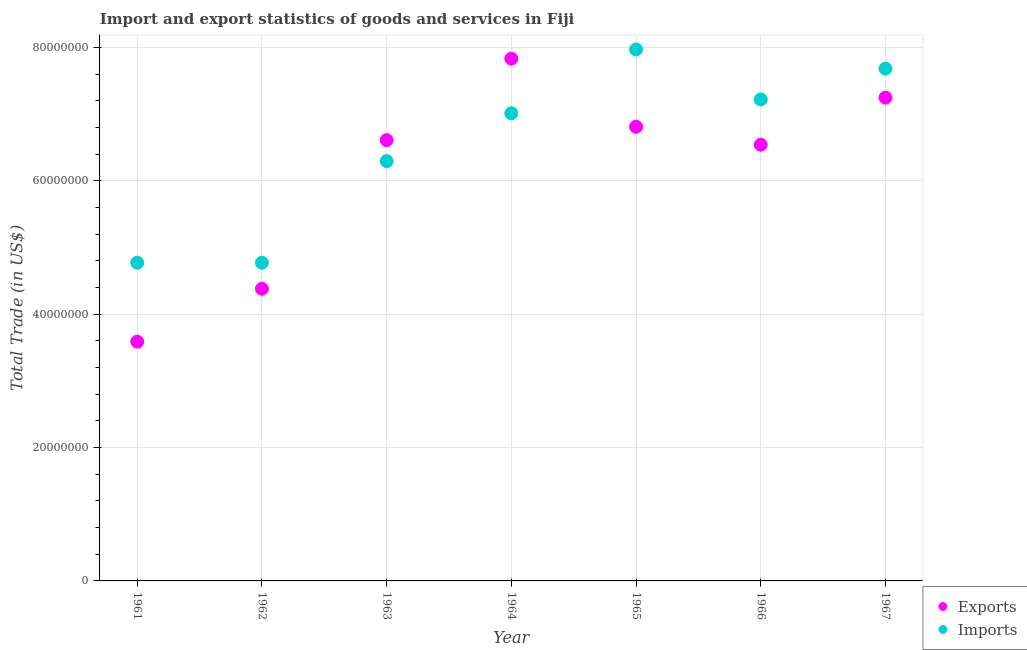How many different coloured dotlines are there?
Give a very brief answer. 2. What is the imports of goods and services in 1966?
Your answer should be very brief. 7.22e+07. Across all years, what is the maximum export of goods and services?
Your response must be concise. 7.83e+07. Across all years, what is the minimum imports of goods and services?
Ensure brevity in your answer.  4.77e+07. In which year was the export of goods and services maximum?
Your answer should be very brief. 1964. What is the total export of goods and services in the graph?
Make the answer very short. 4.30e+08. What is the difference between the export of goods and services in 1965 and that in 1967?
Make the answer very short. -4.36e+06. What is the difference between the export of goods and services in 1962 and the imports of goods and services in 1961?
Keep it short and to the point. -3.90e+06. What is the average export of goods and services per year?
Offer a terse response. 6.15e+07. In the year 1963, what is the difference between the imports of goods and services and export of goods and services?
Keep it short and to the point. -3.15e+06. What is the ratio of the imports of goods and services in 1962 to that in 1965?
Your answer should be very brief. 0.6. What is the difference between the highest and the second highest imports of goods and services?
Keep it short and to the point. 2.88e+06. What is the difference between the highest and the lowest imports of goods and services?
Keep it short and to the point. 3.20e+07. Is the sum of the imports of goods and services in 1965 and 1966 greater than the maximum export of goods and services across all years?
Offer a very short reply. Yes. Is the export of goods and services strictly greater than the imports of goods and services over the years?
Your response must be concise. No. How many dotlines are there?
Provide a succinct answer. 2. How many years are there in the graph?
Keep it short and to the point. 7. What is the difference between two consecutive major ticks on the Y-axis?
Your answer should be very brief. 2.00e+07. Does the graph contain any zero values?
Make the answer very short. No. How are the legend labels stacked?
Offer a terse response. Vertical. What is the title of the graph?
Keep it short and to the point. Import and export statistics of goods and services in Fiji. What is the label or title of the X-axis?
Keep it short and to the point. Year. What is the label or title of the Y-axis?
Your answer should be compact. Total Trade (in US$). What is the Total Trade (in US$) of Exports in 1961?
Your answer should be compact. 3.59e+07. What is the Total Trade (in US$) in Imports in 1961?
Offer a very short reply. 4.77e+07. What is the Total Trade (in US$) of Exports in 1962?
Offer a terse response. 4.38e+07. What is the Total Trade (in US$) of Imports in 1962?
Provide a short and direct response. 4.77e+07. What is the Total Trade (in US$) of Exports in 1963?
Provide a short and direct response. 6.61e+07. What is the Total Trade (in US$) in Imports in 1963?
Keep it short and to the point. 6.30e+07. What is the Total Trade (in US$) of Exports in 1964?
Keep it short and to the point. 7.83e+07. What is the Total Trade (in US$) of Imports in 1964?
Make the answer very short. 7.01e+07. What is the Total Trade (in US$) of Exports in 1965?
Make the answer very short. 6.81e+07. What is the Total Trade (in US$) of Imports in 1965?
Give a very brief answer. 7.97e+07. What is the Total Trade (in US$) in Exports in 1966?
Give a very brief answer. 6.54e+07. What is the Total Trade (in US$) in Imports in 1966?
Your response must be concise. 7.22e+07. What is the Total Trade (in US$) in Exports in 1967?
Your response must be concise. 7.25e+07. What is the Total Trade (in US$) in Imports in 1967?
Ensure brevity in your answer.  7.68e+07. Across all years, what is the maximum Total Trade (in US$) of Exports?
Keep it short and to the point. 7.83e+07. Across all years, what is the maximum Total Trade (in US$) in Imports?
Your answer should be compact. 7.97e+07. Across all years, what is the minimum Total Trade (in US$) in Exports?
Your response must be concise. 3.59e+07. Across all years, what is the minimum Total Trade (in US$) in Imports?
Ensure brevity in your answer.  4.77e+07. What is the total Total Trade (in US$) of Exports in the graph?
Provide a succinct answer. 4.30e+08. What is the total Total Trade (in US$) in Imports in the graph?
Keep it short and to the point. 4.57e+08. What is the difference between the Total Trade (in US$) in Exports in 1961 and that in 1962?
Ensure brevity in your answer.  -7.93e+06. What is the difference between the Total Trade (in US$) of Imports in 1961 and that in 1962?
Give a very brief answer. 0. What is the difference between the Total Trade (in US$) in Exports in 1961 and that in 1963?
Make the answer very short. -3.02e+07. What is the difference between the Total Trade (in US$) of Imports in 1961 and that in 1963?
Keep it short and to the point. -1.52e+07. What is the difference between the Total Trade (in US$) of Exports in 1961 and that in 1964?
Provide a short and direct response. -4.24e+07. What is the difference between the Total Trade (in US$) in Imports in 1961 and that in 1964?
Your response must be concise. -2.24e+07. What is the difference between the Total Trade (in US$) in Exports in 1961 and that in 1965?
Keep it short and to the point. -3.22e+07. What is the difference between the Total Trade (in US$) in Imports in 1961 and that in 1965?
Ensure brevity in your answer.  -3.20e+07. What is the difference between the Total Trade (in US$) of Exports in 1961 and that in 1966?
Make the answer very short. -2.95e+07. What is the difference between the Total Trade (in US$) of Imports in 1961 and that in 1966?
Your answer should be very brief. -2.45e+07. What is the difference between the Total Trade (in US$) of Exports in 1961 and that in 1967?
Your response must be concise. -3.66e+07. What is the difference between the Total Trade (in US$) of Imports in 1961 and that in 1967?
Keep it short and to the point. -2.91e+07. What is the difference between the Total Trade (in US$) in Exports in 1962 and that in 1963?
Keep it short and to the point. -2.23e+07. What is the difference between the Total Trade (in US$) in Imports in 1962 and that in 1963?
Your response must be concise. -1.52e+07. What is the difference between the Total Trade (in US$) in Exports in 1962 and that in 1964?
Provide a short and direct response. -3.45e+07. What is the difference between the Total Trade (in US$) in Imports in 1962 and that in 1964?
Your answer should be compact. -2.24e+07. What is the difference between the Total Trade (in US$) in Exports in 1962 and that in 1965?
Give a very brief answer. -2.43e+07. What is the difference between the Total Trade (in US$) in Imports in 1962 and that in 1965?
Make the answer very short. -3.20e+07. What is the difference between the Total Trade (in US$) in Exports in 1962 and that in 1966?
Offer a very short reply. -2.16e+07. What is the difference between the Total Trade (in US$) in Imports in 1962 and that in 1966?
Your response must be concise. -2.45e+07. What is the difference between the Total Trade (in US$) of Exports in 1962 and that in 1967?
Ensure brevity in your answer.  -2.87e+07. What is the difference between the Total Trade (in US$) of Imports in 1962 and that in 1967?
Offer a very short reply. -2.91e+07. What is the difference between the Total Trade (in US$) in Exports in 1963 and that in 1964?
Offer a very short reply. -1.22e+07. What is the difference between the Total Trade (in US$) of Imports in 1963 and that in 1964?
Your response must be concise. -7.18e+06. What is the difference between the Total Trade (in US$) of Exports in 1963 and that in 1965?
Offer a very short reply. -2.01e+06. What is the difference between the Total Trade (in US$) of Imports in 1963 and that in 1965?
Keep it short and to the point. -1.67e+07. What is the difference between the Total Trade (in US$) in Exports in 1963 and that in 1966?
Ensure brevity in your answer.  6.91e+05. What is the difference between the Total Trade (in US$) of Imports in 1963 and that in 1966?
Your response must be concise. -9.25e+06. What is the difference between the Total Trade (in US$) in Exports in 1963 and that in 1967?
Make the answer very short. -6.37e+06. What is the difference between the Total Trade (in US$) in Imports in 1963 and that in 1967?
Ensure brevity in your answer.  -1.39e+07. What is the difference between the Total Trade (in US$) of Exports in 1964 and that in 1965?
Your answer should be very brief. 1.02e+07. What is the difference between the Total Trade (in US$) in Imports in 1964 and that in 1965?
Your answer should be compact. -9.57e+06. What is the difference between the Total Trade (in US$) in Exports in 1964 and that in 1966?
Give a very brief answer. 1.29e+07. What is the difference between the Total Trade (in US$) of Imports in 1964 and that in 1966?
Your answer should be very brief. -2.07e+06. What is the difference between the Total Trade (in US$) of Exports in 1964 and that in 1967?
Offer a terse response. 5.85e+06. What is the difference between the Total Trade (in US$) of Imports in 1964 and that in 1967?
Your answer should be compact. -6.69e+06. What is the difference between the Total Trade (in US$) in Exports in 1965 and that in 1966?
Make the answer very short. 2.70e+06. What is the difference between the Total Trade (in US$) in Imports in 1965 and that in 1966?
Make the answer very short. 7.49e+06. What is the difference between the Total Trade (in US$) in Exports in 1965 and that in 1967?
Provide a succinct answer. -4.36e+06. What is the difference between the Total Trade (in US$) in Imports in 1965 and that in 1967?
Your answer should be very brief. 2.88e+06. What is the difference between the Total Trade (in US$) of Exports in 1966 and that in 1967?
Keep it short and to the point. -7.06e+06. What is the difference between the Total Trade (in US$) of Imports in 1966 and that in 1967?
Make the answer very short. -4.62e+06. What is the difference between the Total Trade (in US$) of Exports in 1961 and the Total Trade (in US$) of Imports in 1962?
Offer a very short reply. -1.18e+07. What is the difference between the Total Trade (in US$) of Exports in 1961 and the Total Trade (in US$) of Imports in 1963?
Your response must be concise. -2.71e+07. What is the difference between the Total Trade (in US$) of Exports in 1961 and the Total Trade (in US$) of Imports in 1964?
Give a very brief answer. -3.43e+07. What is the difference between the Total Trade (in US$) of Exports in 1961 and the Total Trade (in US$) of Imports in 1965?
Keep it short and to the point. -4.38e+07. What is the difference between the Total Trade (in US$) in Exports in 1961 and the Total Trade (in US$) in Imports in 1966?
Provide a short and direct response. -3.63e+07. What is the difference between the Total Trade (in US$) in Exports in 1961 and the Total Trade (in US$) in Imports in 1967?
Your answer should be very brief. -4.09e+07. What is the difference between the Total Trade (in US$) of Exports in 1962 and the Total Trade (in US$) of Imports in 1963?
Provide a succinct answer. -1.91e+07. What is the difference between the Total Trade (in US$) of Exports in 1962 and the Total Trade (in US$) of Imports in 1964?
Your response must be concise. -2.63e+07. What is the difference between the Total Trade (in US$) in Exports in 1962 and the Total Trade (in US$) in Imports in 1965?
Offer a very short reply. -3.59e+07. What is the difference between the Total Trade (in US$) in Exports in 1962 and the Total Trade (in US$) in Imports in 1966?
Provide a short and direct response. -2.84e+07. What is the difference between the Total Trade (in US$) in Exports in 1962 and the Total Trade (in US$) in Imports in 1967?
Ensure brevity in your answer.  -3.30e+07. What is the difference between the Total Trade (in US$) of Exports in 1963 and the Total Trade (in US$) of Imports in 1964?
Provide a short and direct response. -4.03e+06. What is the difference between the Total Trade (in US$) of Exports in 1963 and the Total Trade (in US$) of Imports in 1965?
Provide a succinct answer. -1.36e+07. What is the difference between the Total Trade (in US$) in Exports in 1963 and the Total Trade (in US$) in Imports in 1966?
Ensure brevity in your answer.  -6.10e+06. What is the difference between the Total Trade (in US$) in Exports in 1963 and the Total Trade (in US$) in Imports in 1967?
Offer a very short reply. -1.07e+07. What is the difference between the Total Trade (in US$) of Exports in 1964 and the Total Trade (in US$) of Imports in 1965?
Provide a succinct answer. -1.38e+06. What is the difference between the Total Trade (in US$) in Exports in 1964 and the Total Trade (in US$) in Imports in 1966?
Your answer should be very brief. 6.11e+06. What is the difference between the Total Trade (in US$) in Exports in 1964 and the Total Trade (in US$) in Imports in 1967?
Offer a very short reply. 1.49e+06. What is the difference between the Total Trade (in US$) in Exports in 1965 and the Total Trade (in US$) in Imports in 1966?
Provide a succinct answer. -4.09e+06. What is the difference between the Total Trade (in US$) of Exports in 1965 and the Total Trade (in US$) of Imports in 1967?
Your response must be concise. -8.71e+06. What is the difference between the Total Trade (in US$) in Exports in 1966 and the Total Trade (in US$) in Imports in 1967?
Offer a very short reply. -1.14e+07. What is the average Total Trade (in US$) in Exports per year?
Your answer should be very brief. 6.15e+07. What is the average Total Trade (in US$) of Imports per year?
Offer a very short reply. 6.53e+07. In the year 1961, what is the difference between the Total Trade (in US$) of Exports and Total Trade (in US$) of Imports?
Ensure brevity in your answer.  -1.18e+07. In the year 1962, what is the difference between the Total Trade (in US$) in Exports and Total Trade (in US$) in Imports?
Make the answer very short. -3.90e+06. In the year 1963, what is the difference between the Total Trade (in US$) of Exports and Total Trade (in US$) of Imports?
Your answer should be compact. 3.15e+06. In the year 1964, what is the difference between the Total Trade (in US$) of Exports and Total Trade (in US$) of Imports?
Provide a short and direct response. 8.19e+06. In the year 1965, what is the difference between the Total Trade (in US$) in Exports and Total Trade (in US$) in Imports?
Make the answer very short. -1.16e+07. In the year 1966, what is the difference between the Total Trade (in US$) in Exports and Total Trade (in US$) in Imports?
Provide a short and direct response. -6.79e+06. In the year 1967, what is the difference between the Total Trade (in US$) of Exports and Total Trade (in US$) of Imports?
Offer a very short reply. -4.35e+06. What is the ratio of the Total Trade (in US$) of Exports in 1961 to that in 1962?
Make the answer very short. 0.82. What is the ratio of the Total Trade (in US$) of Exports in 1961 to that in 1963?
Keep it short and to the point. 0.54. What is the ratio of the Total Trade (in US$) of Imports in 1961 to that in 1963?
Provide a succinct answer. 0.76. What is the ratio of the Total Trade (in US$) in Exports in 1961 to that in 1964?
Make the answer very short. 0.46. What is the ratio of the Total Trade (in US$) of Imports in 1961 to that in 1964?
Your answer should be compact. 0.68. What is the ratio of the Total Trade (in US$) in Exports in 1961 to that in 1965?
Provide a short and direct response. 0.53. What is the ratio of the Total Trade (in US$) in Imports in 1961 to that in 1965?
Provide a succinct answer. 0.6. What is the ratio of the Total Trade (in US$) in Exports in 1961 to that in 1966?
Provide a short and direct response. 0.55. What is the ratio of the Total Trade (in US$) in Imports in 1961 to that in 1966?
Offer a terse response. 0.66. What is the ratio of the Total Trade (in US$) in Exports in 1961 to that in 1967?
Offer a terse response. 0.5. What is the ratio of the Total Trade (in US$) in Imports in 1961 to that in 1967?
Your response must be concise. 0.62. What is the ratio of the Total Trade (in US$) in Exports in 1962 to that in 1963?
Your response must be concise. 0.66. What is the ratio of the Total Trade (in US$) of Imports in 1962 to that in 1963?
Offer a very short reply. 0.76. What is the ratio of the Total Trade (in US$) in Exports in 1962 to that in 1964?
Provide a short and direct response. 0.56. What is the ratio of the Total Trade (in US$) in Imports in 1962 to that in 1964?
Your response must be concise. 0.68. What is the ratio of the Total Trade (in US$) in Exports in 1962 to that in 1965?
Give a very brief answer. 0.64. What is the ratio of the Total Trade (in US$) in Imports in 1962 to that in 1965?
Ensure brevity in your answer.  0.6. What is the ratio of the Total Trade (in US$) of Exports in 1962 to that in 1966?
Make the answer very short. 0.67. What is the ratio of the Total Trade (in US$) in Imports in 1962 to that in 1966?
Your answer should be compact. 0.66. What is the ratio of the Total Trade (in US$) in Exports in 1962 to that in 1967?
Make the answer very short. 0.6. What is the ratio of the Total Trade (in US$) in Imports in 1962 to that in 1967?
Provide a succinct answer. 0.62. What is the ratio of the Total Trade (in US$) of Exports in 1963 to that in 1964?
Your answer should be compact. 0.84. What is the ratio of the Total Trade (in US$) of Imports in 1963 to that in 1964?
Your response must be concise. 0.9. What is the ratio of the Total Trade (in US$) of Exports in 1963 to that in 1965?
Offer a terse response. 0.97. What is the ratio of the Total Trade (in US$) of Imports in 1963 to that in 1965?
Offer a terse response. 0.79. What is the ratio of the Total Trade (in US$) in Exports in 1963 to that in 1966?
Your response must be concise. 1.01. What is the ratio of the Total Trade (in US$) of Imports in 1963 to that in 1966?
Your answer should be compact. 0.87. What is the ratio of the Total Trade (in US$) in Exports in 1963 to that in 1967?
Your response must be concise. 0.91. What is the ratio of the Total Trade (in US$) of Imports in 1963 to that in 1967?
Your answer should be very brief. 0.82. What is the ratio of the Total Trade (in US$) of Exports in 1964 to that in 1965?
Your response must be concise. 1.15. What is the ratio of the Total Trade (in US$) in Imports in 1964 to that in 1965?
Ensure brevity in your answer.  0.88. What is the ratio of the Total Trade (in US$) of Exports in 1964 to that in 1966?
Offer a terse response. 1.2. What is the ratio of the Total Trade (in US$) of Imports in 1964 to that in 1966?
Your answer should be very brief. 0.97. What is the ratio of the Total Trade (in US$) in Exports in 1964 to that in 1967?
Keep it short and to the point. 1.08. What is the ratio of the Total Trade (in US$) in Imports in 1964 to that in 1967?
Provide a short and direct response. 0.91. What is the ratio of the Total Trade (in US$) of Exports in 1965 to that in 1966?
Offer a terse response. 1.04. What is the ratio of the Total Trade (in US$) of Imports in 1965 to that in 1966?
Provide a succinct answer. 1.1. What is the ratio of the Total Trade (in US$) of Exports in 1965 to that in 1967?
Make the answer very short. 0.94. What is the ratio of the Total Trade (in US$) of Imports in 1965 to that in 1967?
Your answer should be very brief. 1.04. What is the ratio of the Total Trade (in US$) in Exports in 1966 to that in 1967?
Make the answer very short. 0.9. What is the ratio of the Total Trade (in US$) of Imports in 1966 to that in 1967?
Make the answer very short. 0.94. What is the difference between the highest and the second highest Total Trade (in US$) of Exports?
Ensure brevity in your answer.  5.85e+06. What is the difference between the highest and the second highest Total Trade (in US$) of Imports?
Keep it short and to the point. 2.88e+06. What is the difference between the highest and the lowest Total Trade (in US$) in Exports?
Keep it short and to the point. 4.24e+07. What is the difference between the highest and the lowest Total Trade (in US$) in Imports?
Ensure brevity in your answer.  3.20e+07. 